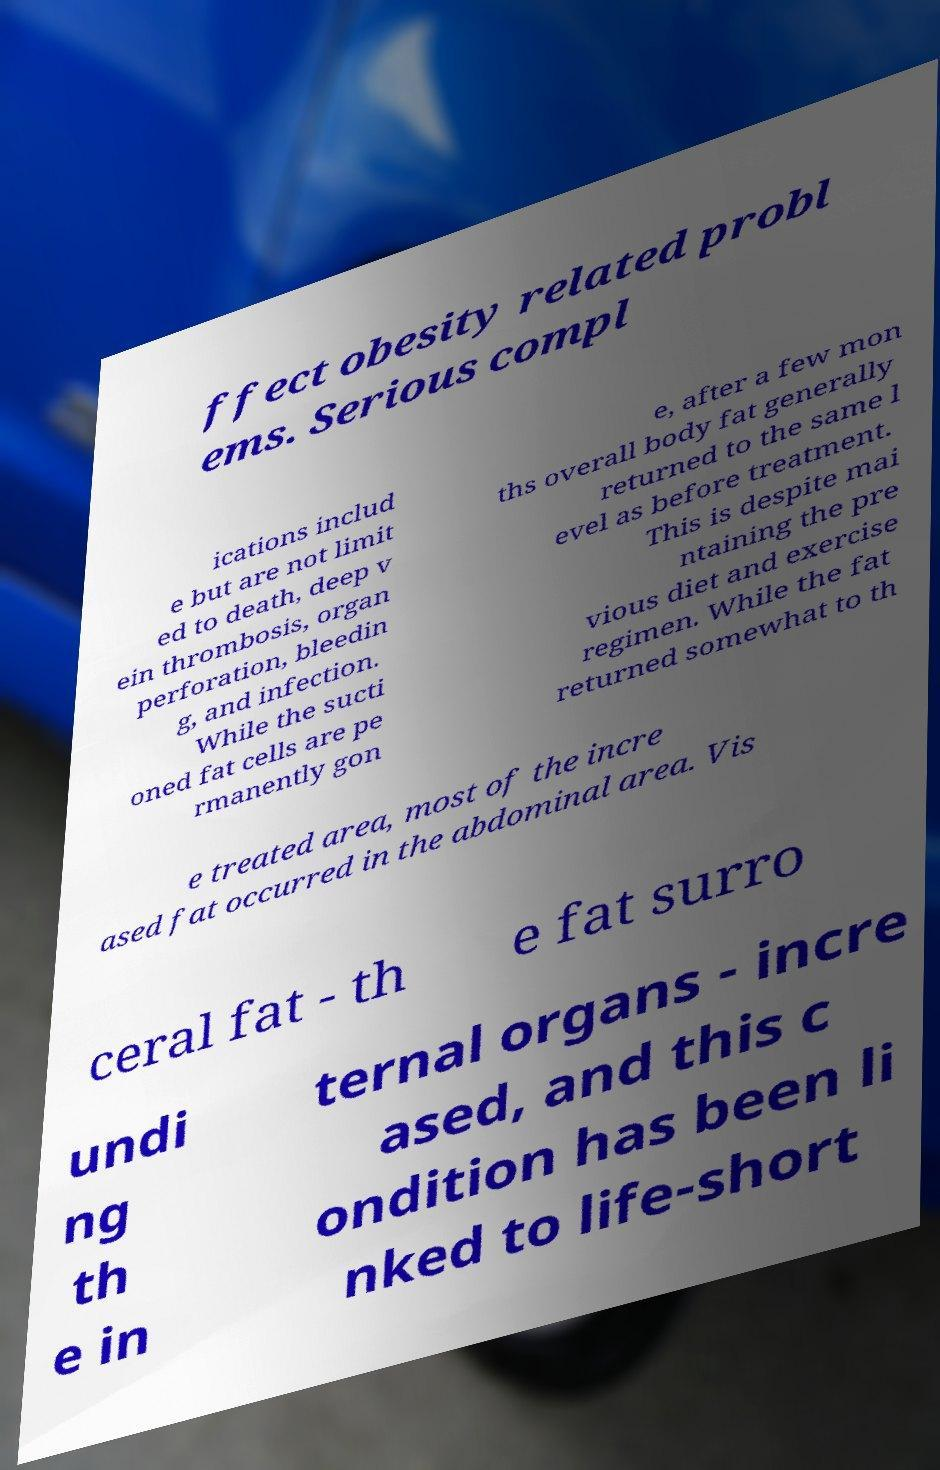Please read and relay the text visible in this image. What does it say? ffect obesity related probl ems. Serious compl ications includ e but are not limit ed to death, deep v ein thrombosis, organ perforation, bleedin g, and infection. While the sucti oned fat cells are pe rmanently gon e, after a few mon ths overall body fat generally returned to the same l evel as before treatment. This is despite mai ntaining the pre vious diet and exercise regimen. While the fat returned somewhat to th e treated area, most of the incre ased fat occurred in the abdominal area. Vis ceral fat - th e fat surro undi ng th e in ternal organs - incre ased, and this c ondition has been li nked to life-short 